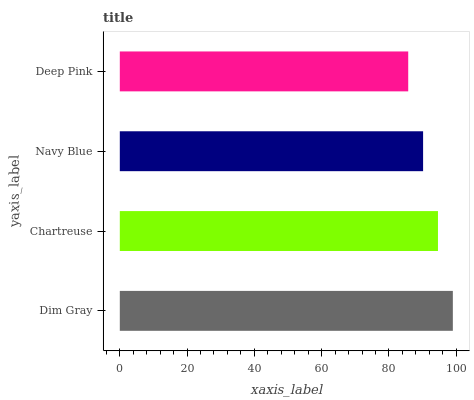Is Deep Pink the minimum?
Answer yes or no. Yes. Is Dim Gray the maximum?
Answer yes or no. Yes. Is Chartreuse the minimum?
Answer yes or no. No. Is Chartreuse the maximum?
Answer yes or no. No. Is Dim Gray greater than Chartreuse?
Answer yes or no. Yes. Is Chartreuse less than Dim Gray?
Answer yes or no. Yes. Is Chartreuse greater than Dim Gray?
Answer yes or no. No. Is Dim Gray less than Chartreuse?
Answer yes or no. No. Is Chartreuse the high median?
Answer yes or no. Yes. Is Navy Blue the low median?
Answer yes or no. Yes. Is Dim Gray the high median?
Answer yes or no. No. Is Chartreuse the low median?
Answer yes or no. No. 